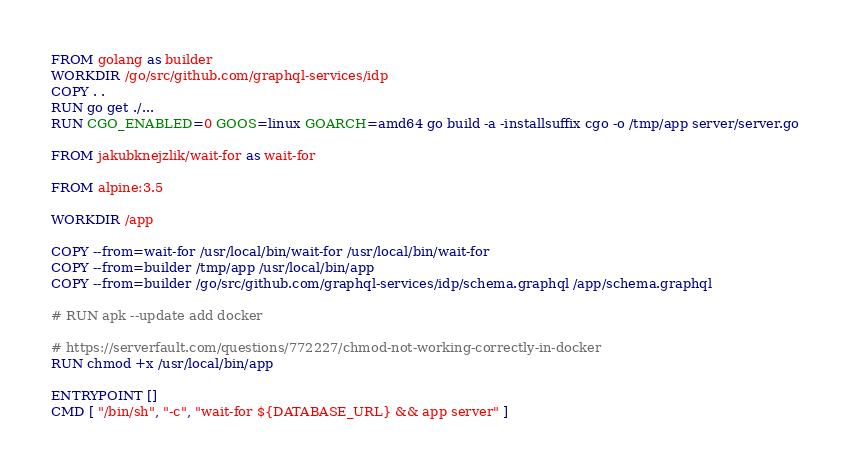<code> <loc_0><loc_0><loc_500><loc_500><_Dockerfile_>FROM golang as builder
WORKDIR /go/src/github.com/graphql-services/idp
COPY . .
RUN go get ./... 
RUN CGO_ENABLED=0 GOOS=linux GOARCH=amd64 go build -a -installsuffix cgo -o /tmp/app server/server.go

FROM jakubknejzlik/wait-for as wait-for

FROM alpine:3.5

WORKDIR /app

COPY --from=wait-for /usr/local/bin/wait-for /usr/local/bin/wait-for
COPY --from=builder /tmp/app /usr/local/bin/app
COPY --from=builder /go/src/github.com/graphql-services/idp/schema.graphql /app/schema.graphql

# RUN apk --update add docker

# https://serverfault.com/questions/772227/chmod-not-working-correctly-in-docker
RUN chmod +x /usr/local/bin/app

ENTRYPOINT []
CMD [ "/bin/sh", "-c", "wait-for ${DATABASE_URL} && app server" ]</code> 